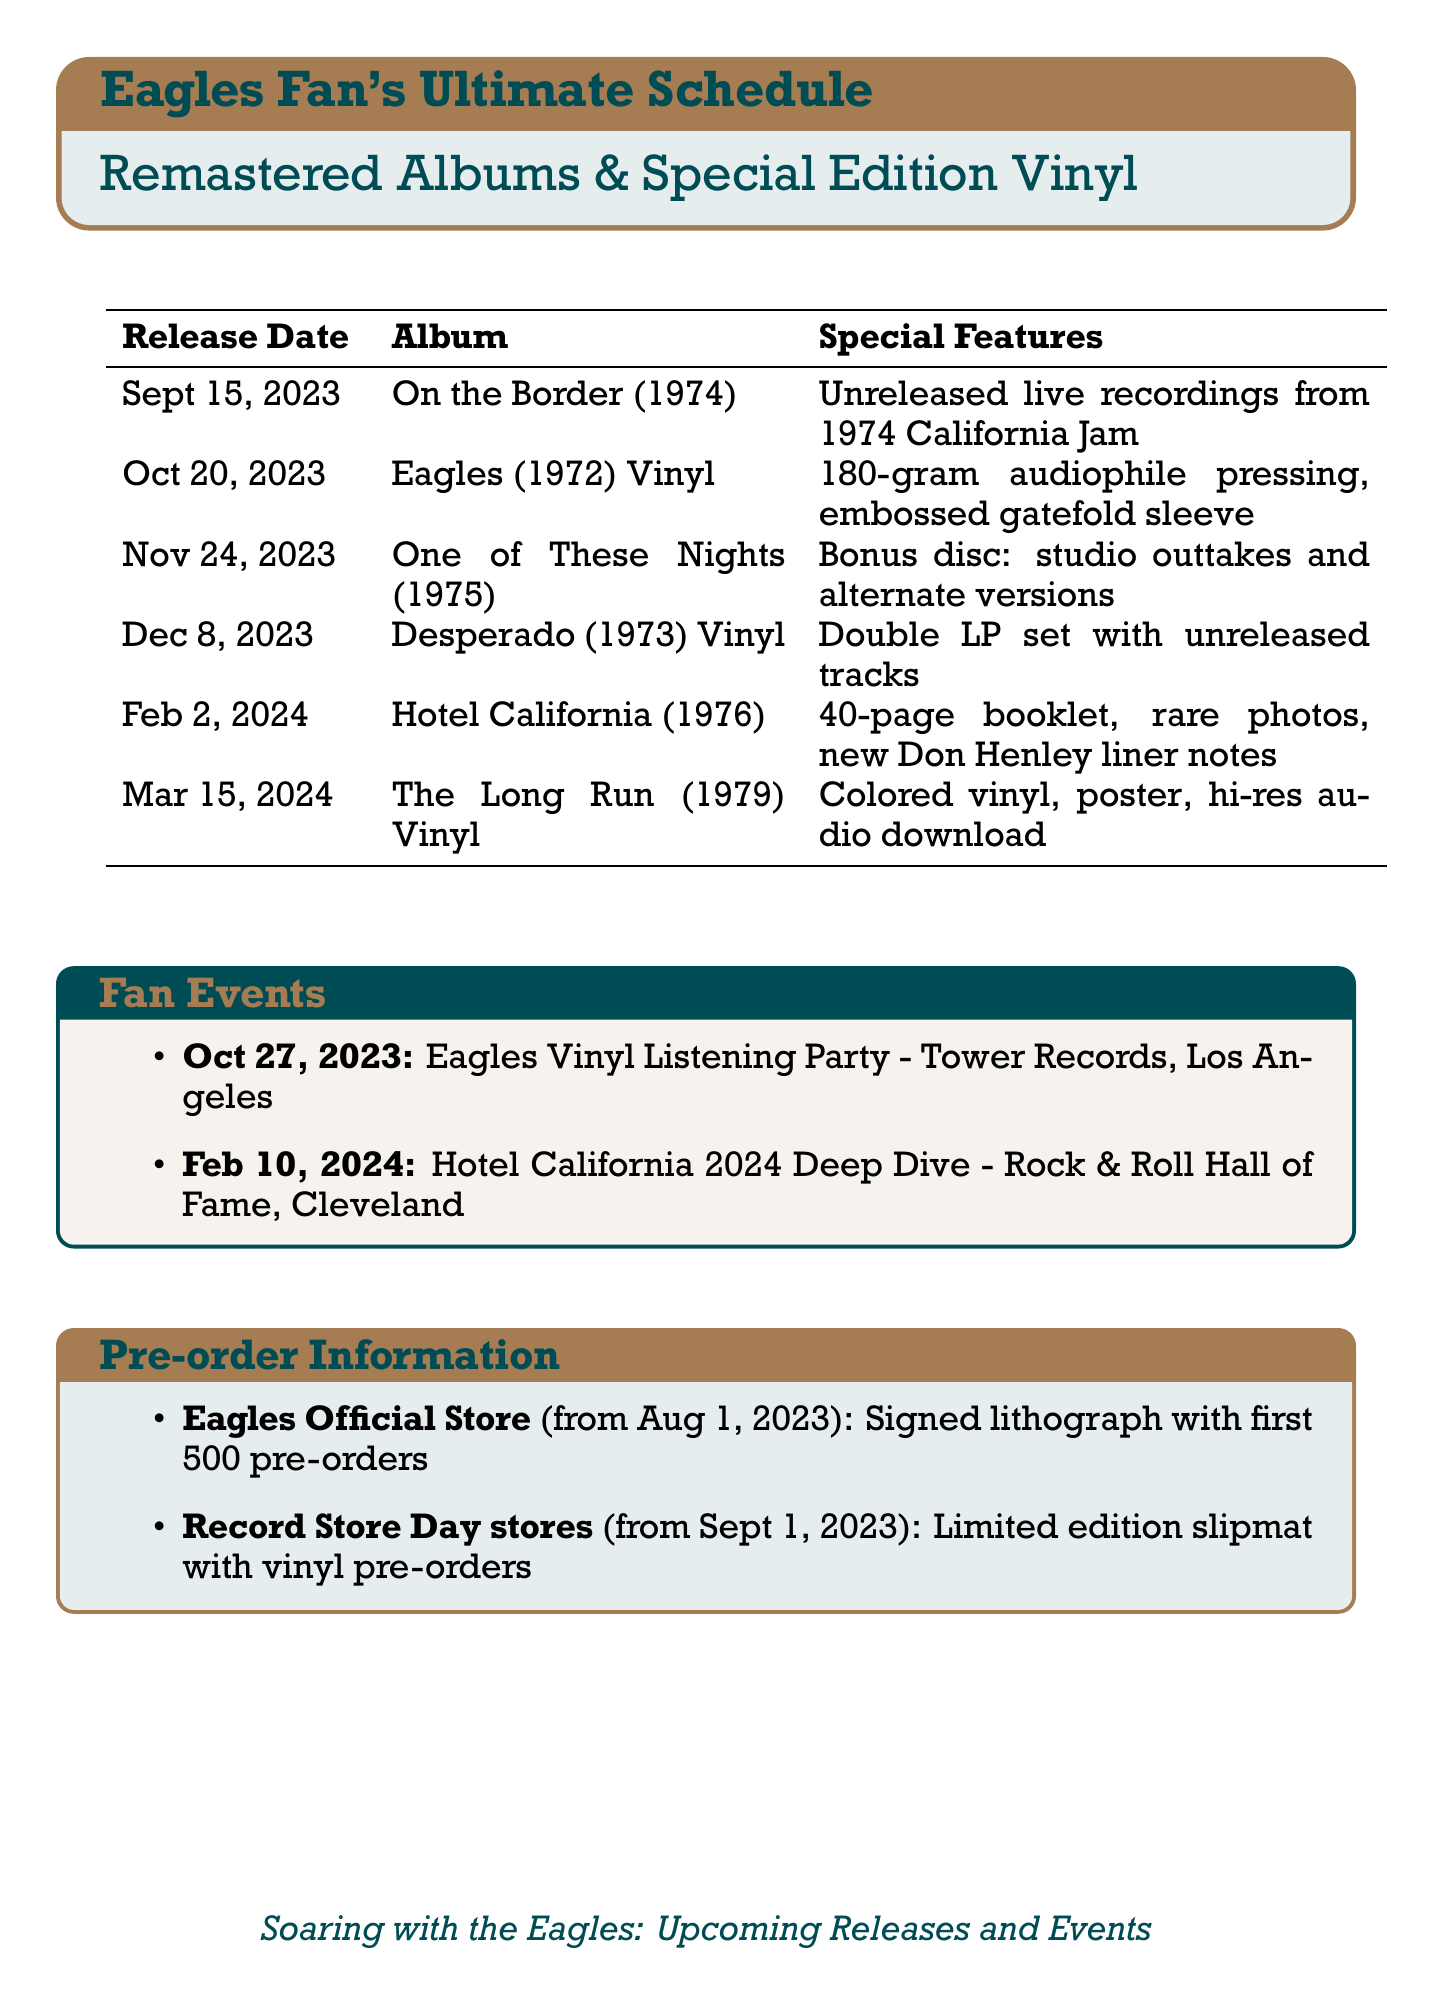What is the remastered release date for "On the Border"? The remastered release date for "On the Border" is specifically mentioned in the document.
Answer: September 15, 2023 What special feature accompanies the remastered "Hotel California"? The specific special feature for the remastered "Hotel California" is described in the document.
Answer: 40-page booklet with rare photos and new liner notes by Don Henley When is the vinyl release for "Desperado"? The document provides a release date for the special edition vinyl of "Desperado."
Answer: December 8, 2023 Which retailer offers a signed lithograph for pre-orders? The document lists retailers and their offers for pre-orders, including the one offering a signed lithograph.
Answer: Eagles Official Store How many tracks are included with the special edition vinyl of "Desperado"? The document states that the special edition vinyl of "Desperado" contains previously unreleased tracks.
Answer: Previously unreleased tracks What event takes place on February 10, 2024? The document includes details about fan events and their dates, including that specific date.
Answer: Hotel California 2024 Deep Dive What is the exclusive offer for the first 500 pre-orders of any remastered album? The document highlights exclusive offers for pre-orders, specifically for the first 500 pre-orders of any remastered album.
Answer: Signed lithograph What is the format of the "Eagles" vinyl release? The document describes the special edition vinyl release formats, including this particular one.
Answer: 180-gram audiophile pressing 